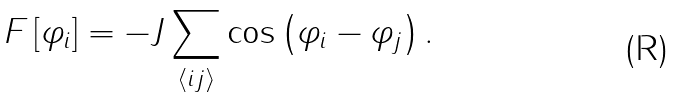<formula> <loc_0><loc_0><loc_500><loc_500>F \left [ \varphi _ { i } \right ] = - J \sum _ { \langle i j \rangle } \cos \left ( \varphi _ { i } - \varphi _ { j } \right ) .</formula> 